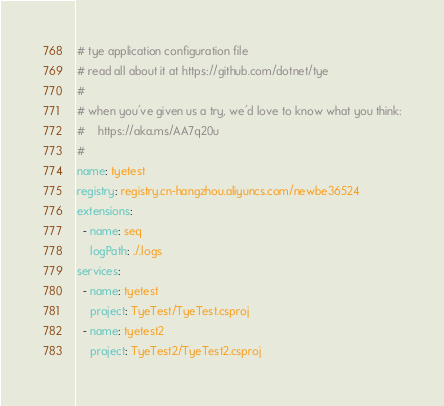Convert code to text. <code><loc_0><loc_0><loc_500><loc_500><_YAML_># tye application configuration file
# read all about it at https://github.com/dotnet/tye
#
# when you've given us a try, we'd love to know what you think:
#    https://aka.ms/AA7q20u
#
name: tyetest
registry: registry.cn-hangzhou.aliyuncs.com/newbe36524
extensions:
  - name: seq
    logPath: ./.logs
services:
  - name: tyetest
    project: TyeTest/TyeTest.csproj
  - name: tyetest2
    project: TyeTest2/TyeTest2.csproj
</code> 